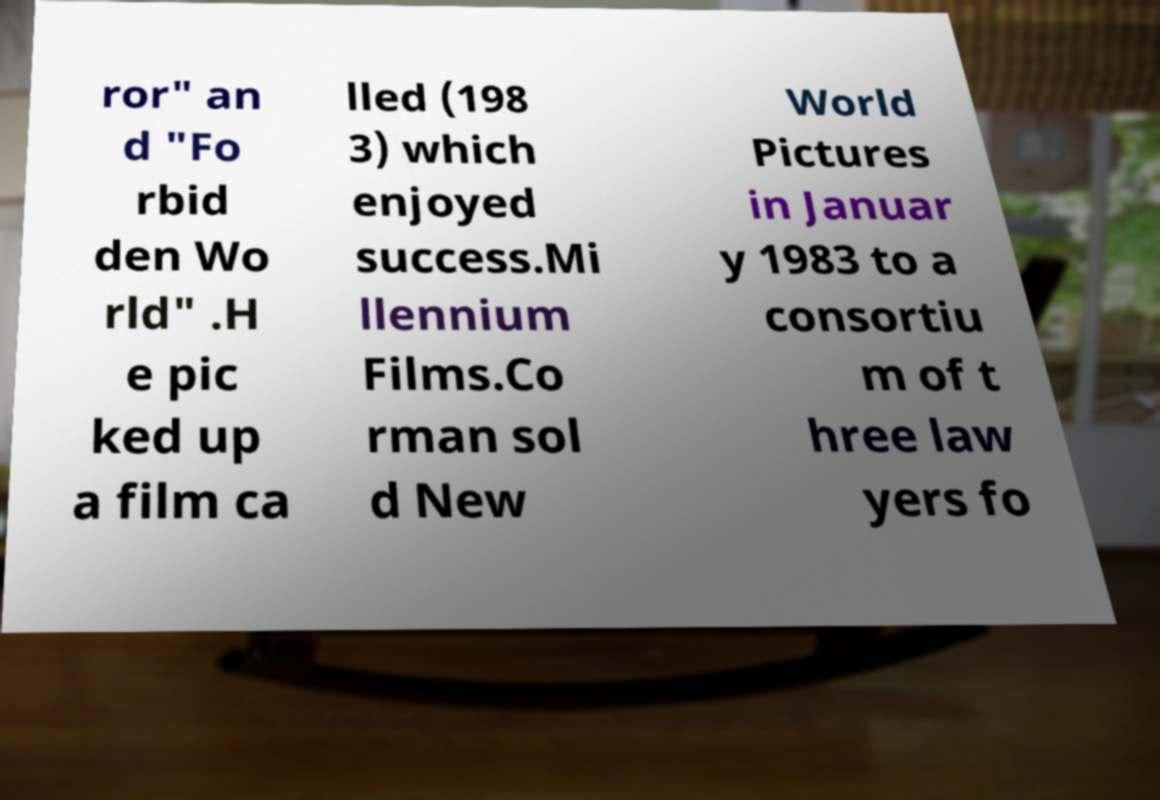Please read and relay the text visible in this image. What does it say? ror" an d "Fo rbid den Wo rld" .H e pic ked up a film ca lled (198 3) which enjoyed success.Mi llennium Films.Co rman sol d New World Pictures in Januar y 1983 to a consortiu m of t hree law yers fo 